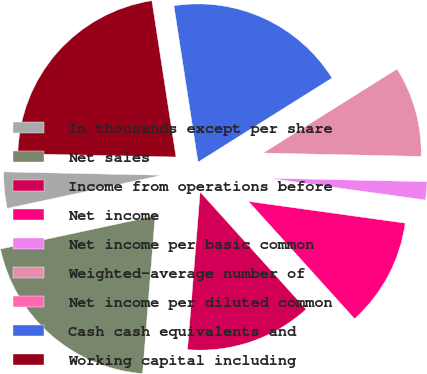Convert chart to OTSL. <chart><loc_0><loc_0><loc_500><loc_500><pie_chart><fcel>In thousands except per share<fcel>Net sales<fcel>Income from operations before<fcel>Net income<fcel>Net income per basic common<fcel>Weighted-average number of<fcel>Net income per diluted common<fcel>Cash cash equivalents and<fcel>Working capital including<nl><fcel>3.7%<fcel>20.37%<fcel>12.96%<fcel>11.11%<fcel>1.85%<fcel>9.26%<fcel>0.0%<fcel>18.52%<fcel>22.22%<nl></chart> 